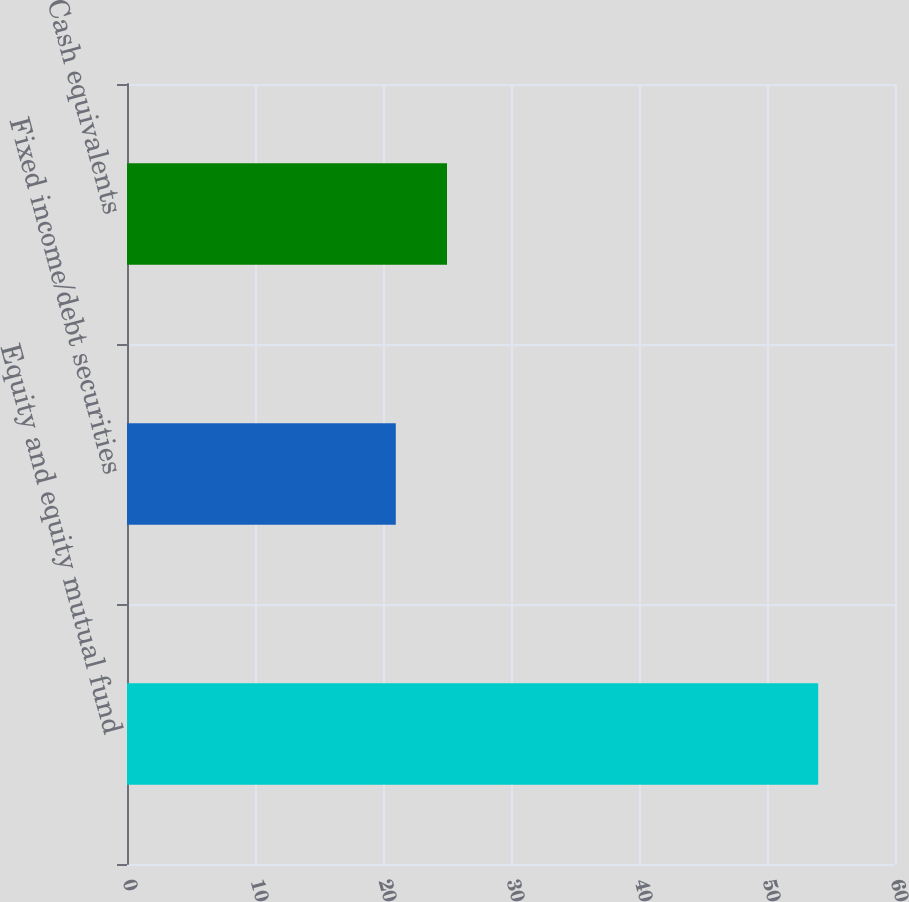Convert chart to OTSL. <chart><loc_0><loc_0><loc_500><loc_500><bar_chart><fcel>Equity and equity mutual fund<fcel>Fixed income/debt securities<fcel>Cash equivalents<nl><fcel>54<fcel>21<fcel>25<nl></chart> 